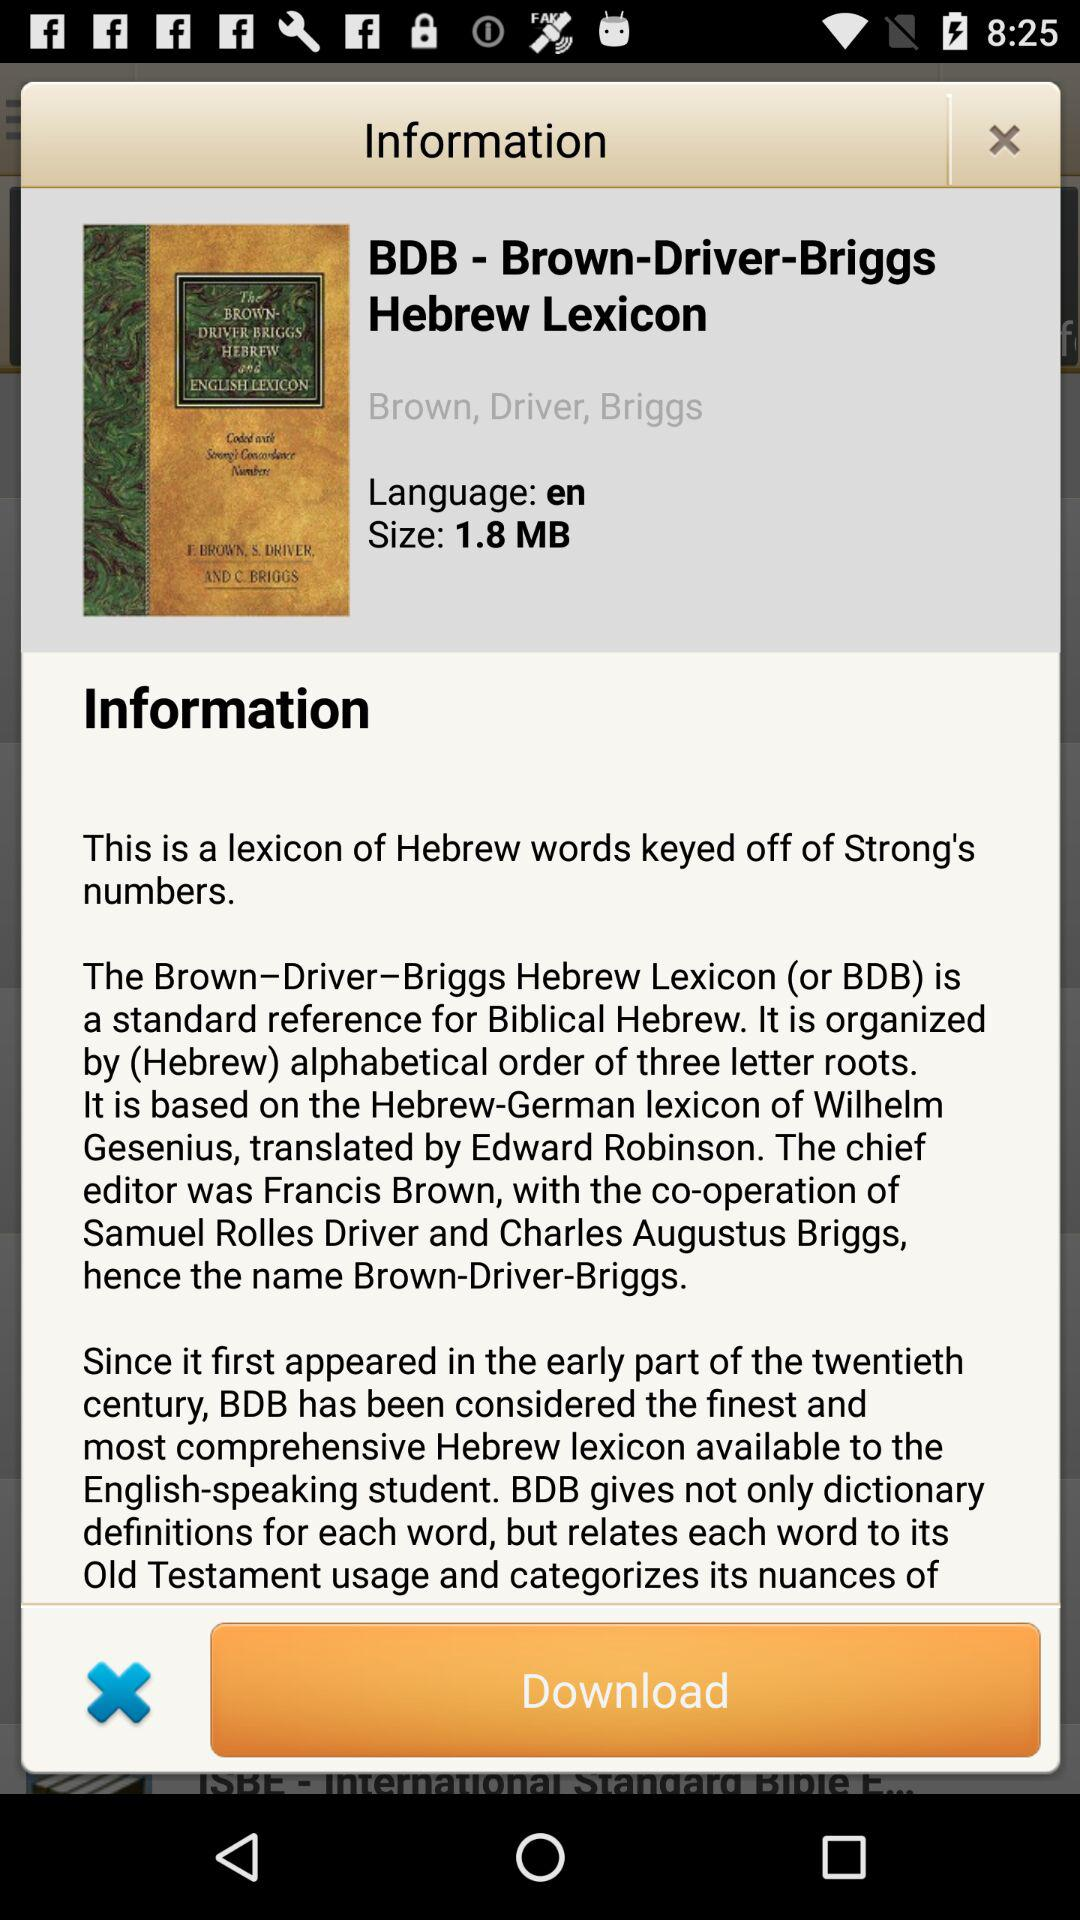What is the size of "Brown-Driver-Briggs-Hebrew-Lexicon"? The size is 1.8 MB. 